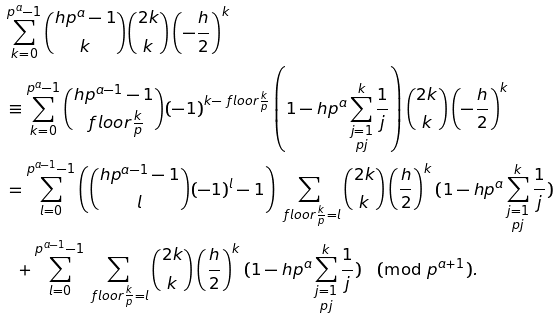<formula> <loc_0><loc_0><loc_500><loc_500>& \sum _ { k = 0 } ^ { p ^ { a } - 1 } \binom { h p ^ { a } - 1 } { k } \binom { 2 k } { k } \left ( - \frac { h } { 2 } \right ) ^ { k } \\ & \equiv \sum _ { k = 0 } ^ { p ^ { a } - 1 } \binom { h p ^ { a - 1 } - 1 } { \ f l o o r { \frac { k } { p } } } ( - 1 ) ^ { k - \ f l o o r { \frac { k } { p } } } \left ( 1 - h p ^ { a } \sum _ { \substack { j = 1 \\ p \nmid j } } ^ { k } \frac { 1 } { j } \right ) \binom { 2 k } { k } \left ( - \frac { h } { 2 } \right ) ^ { k } \\ & = \sum _ { l = 0 } ^ { p ^ { a - 1 } - 1 } \left ( \binom { h p ^ { a - 1 } - 1 } { l } ( - 1 ) ^ { l } - 1 \right ) \sum _ { \ f l o o r { \frac { k } { p } } = l } \binom { 2 k } { k } \left ( \frac { h } { 2 } \right ) ^ { k } ( 1 - h p ^ { a } \sum _ { \substack { j = 1 \\ p \nmid j } } ^ { k } \frac { 1 } { j } ) \\ & \ \ + \sum _ { l = 0 } ^ { p ^ { a - 1 } - 1 } \sum _ { \ f l o o r { \frac { k } { p } } = l } \binom { 2 k } { k } \left ( \frac { h } { 2 } \right ) ^ { k } ( 1 - h p ^ { a } \sum _ { \substack { j = 1 \\ p \nmid j } } ^ { k } \frac { 1 } { j } ) \pmod { p ^ { a + 1 } } .</formula> 